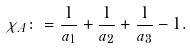<formula> <loc_0><loc_0><loc_500><loc_500>\chi _ { A } \colon = \frac { 1 } { a _ { 1 } } + \frac { 1 } { a _ { 2 } } + \frac { 1 } { a _ { 3 } } - 1 .</formula> 